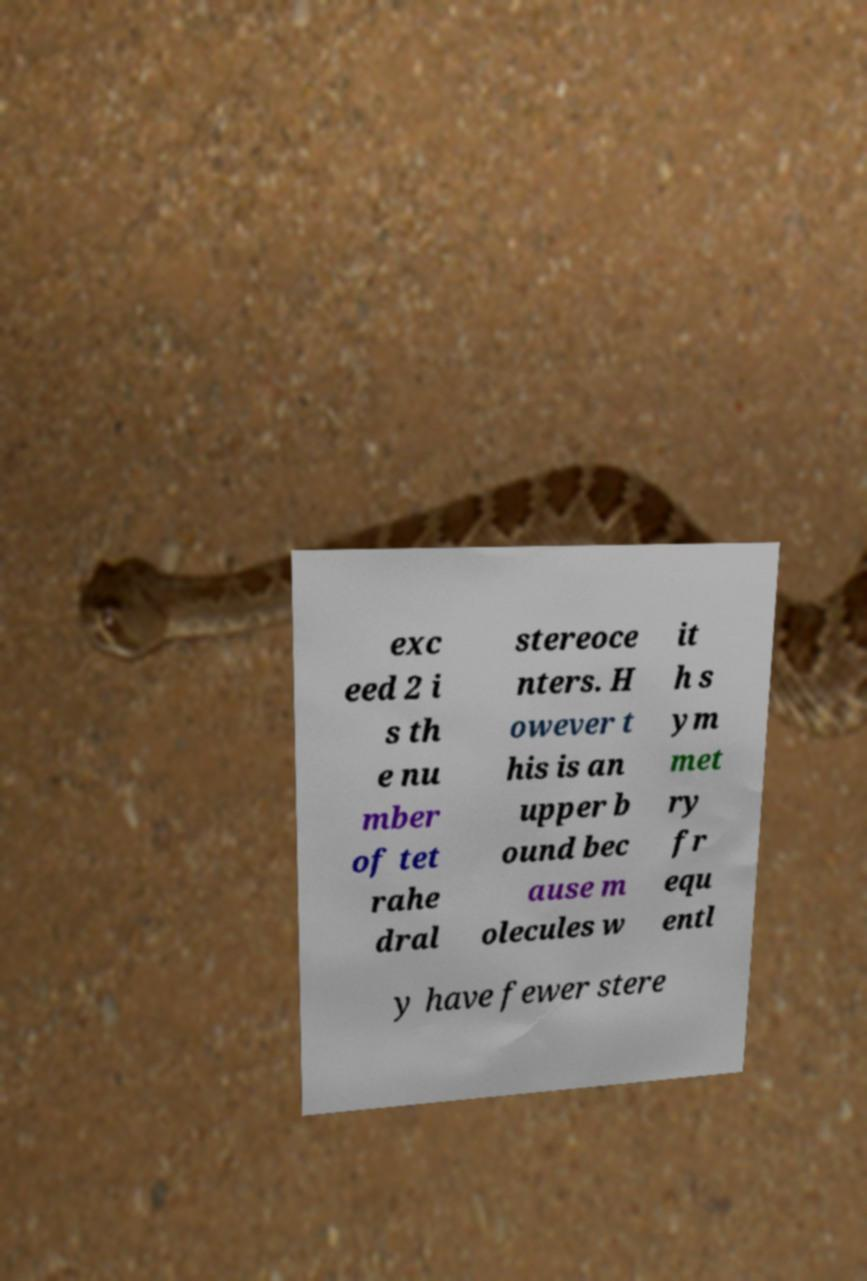Please identify and transcribe the text found in this image. exc eed 2 i s th e nu mber of tet rahe dral stereoce nters. H owever t his is an upper b ound bec ause m olecules w it h s ym met ry fr equ entl y have fewer stere 